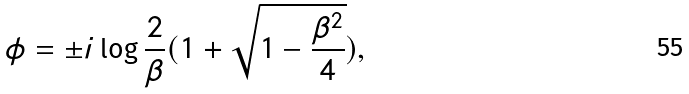Convert formula to latex. <formula><loc_0><loc_0><loc_500><loc_500>\phi = \pm i \log \frac { 2 } { \beta } ( 1 + \sqrt { 1 - \frac { \beta ^ { 2 } } { 4 } } ) ,</formula> 